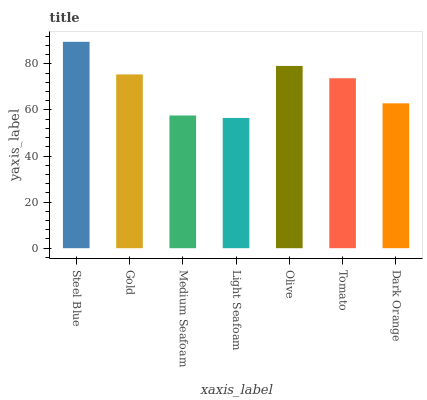Is Light Seafoam the minimum?
Answer yes or no. Yes. Is Steel Blue the maximum?
Answer yes or no. Yes. Is Gold the minimum?
Answer yes or no. No. Is Gold the maximum?
Answer yes or no. No. Is Steel Blue greater than Gold?
Answer yes or no. Yes. Is Gold less than Steel Blue?
Answer yes or no. Yes. Is Gold greater than Steel Blue?
Answer yes or no. No. Is Steel Blue less than Gold?
Answer yes or no. No. Is Tomato the high median?
Answer yes or no. Yes. Is Tomato the low median?
Answer yes or no. Yes. Is Olive the high median?
Answer yes or no. No. Is Dark Orange the low median?
Answer yes or no. No. 